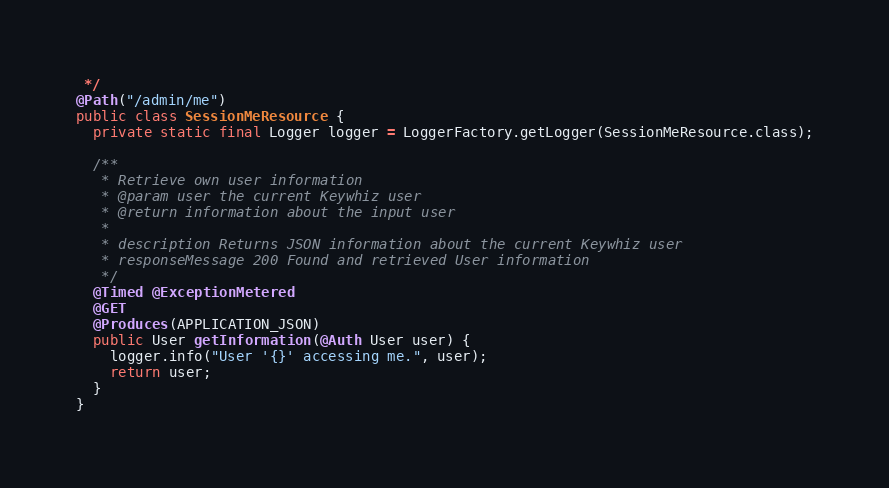Convert code to text. <code><loc_0><loc_0><loc_500><loc_500><_Java_> */
@Path("/admin/me")
public class SessionMeResource {
  private static final Logger logger = LoggerFactory.getLogger(SessionMeResource.class);

  /**
   * Retrieve own user information
   * @param user the current Keywhiz user
   * @return information about the input user
   *
   * description Returns JSON information about the current Keywhiz user
   * responseMessage 200 Found and retrieved User information
   */
  @Timed @ExceptionMetered
  @GET
  @Produces(APPLICATION_JSON)
  public User getInformation(@Auth User user) {
    logger.info("User '{}' accessing me.", user);
    return user;
  }
}
</code> 